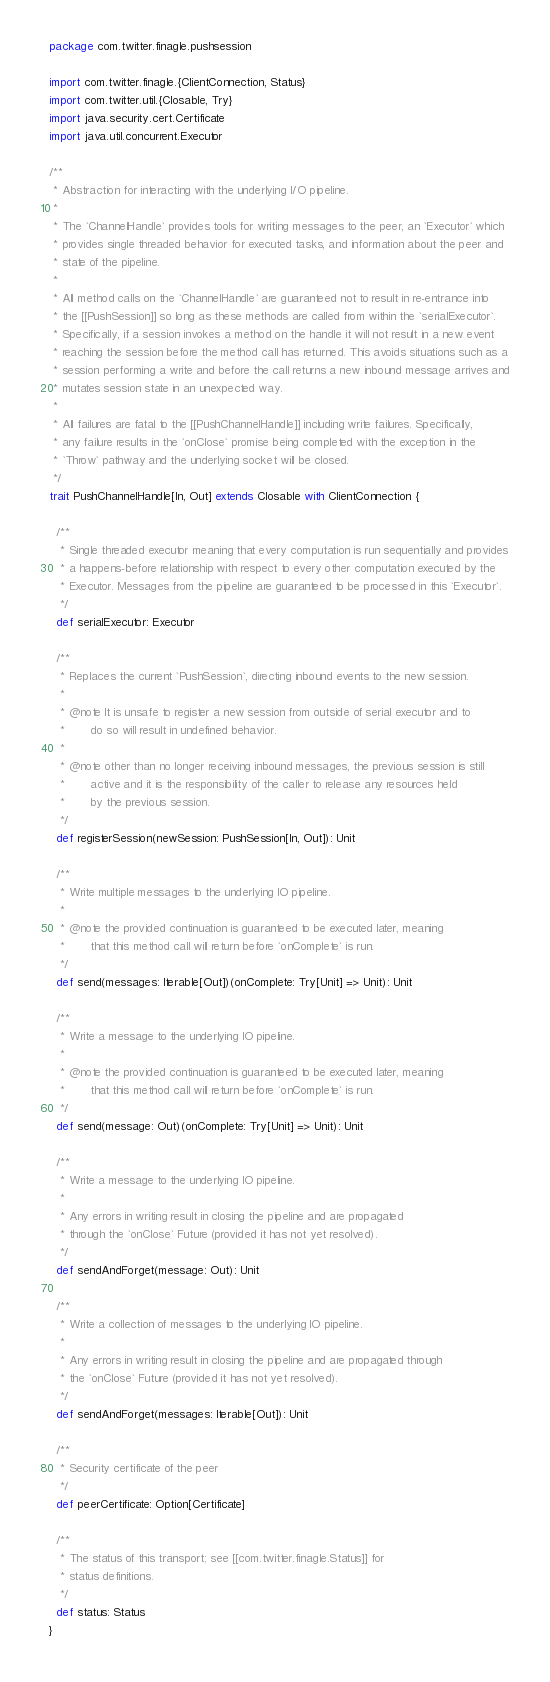<code> <loc_0><loc_0><loc_500><loc_500><_Scala_>package com.twitter.finagle.pushsession

import com.twitter.finagle.{ClientConnection, Status}
import com.twitter.util.{Closable, Try}
import java.security.cert.Certificate
import java.util.concurrent.Executor

/**
 * Abstraction for interacting with the underlying I/O pipeline.
 *
 * The `ChannelHandle` provides tools for writing messages to the peer, an `Executor` which
 * provides single threaded behavior for executed tasks, and information about the peer and
 * state of the pipeline.
 *
 * All method calls on the `ChannelHandle` are guaranteed not to result in re-entrance into
 * the [[PushSession]] so long as these methods are called from within the `serialExecutor`.
 * Specifically, if a session invokes a method on the handle it will not result in a new event
 * reaching the session before the method call has returned. This avoids situations such as a
 * session performing a write and before the call returns a new inbound message arrives and
 * mutates session state in an unexpected way.
 *
 * All failures are fatal to the [[PushChannelHandle]] including write failures. Specifically,
 * any failure results in the `onClose` promise being completed with the exception in the
 * `Throw` pathway and the underlying socket will be closed.
 */
trait PushChannelHandle[In, Out] extends Closable with ClientConnection {

  /**
   * Single threaded executor meaning that every computation is run sequentially and provides
   * a happens-before relationship with respect to every other computation executed by the
   * Executor. Messages from the pipeline are guaranteed to be processed in this `Executor`.
   */
  def serialExecutor: Executor

  /**
   * Replaces the current `PushSession`, directing inbound events to the new session.
   *
   * @note It is unsafe to register a new session from outside of serial executor and to
   *       do so will result in undefined behavior.
   *
   * @note other than no longer receiving inbound messages, the previous session is still
   *       active and it is the responsibility of the caller to release any resources held
   *       by the previous session.
   */
  def registerSession(newSession: PushSession[In, Out]): Unit

  /**
   * Write multiple messages to the underlying IO pipeline.
   *
   * @note the provided continuation is guaranteed to be executed later, meaning
   *       that this method call will return before `onComplete` is run.
   */
  def send(messages: Iterable[Out])(onComplete: Try[Unit] => Unit): Unit

  /**
   * Write a message to the underlying IO pipeline.
   *
   * @note the provided continuation is guaranteed to be executed later, meaning
   *       that this method call will return before `onComplete` is run.
   */
  def send(message: Out)(onComplete: Try[Unit] => Unit): Unit

  /**
   * Write a message to the underlying IO pipeline.
   *
   * Any errors in writing result in closing the pipeline and are propagated
   * through the `onClose` Future (provided it has not yet resolved).
   */
  def sendAndForget(message: Out): Unit

  /**
   * Write a collection of messages to the underlying IO pipeline.
   *
   * Any errors in writing result in closing the pipeline and are propagated through
   * the `onClose` Future (provided it has not yet resolved).
   */
  def sendAndForget(messages: Iterable[Out]): Unit

  /**
   * Security certificate of the peer
   */
  def peerCertificate: Option[Certificate]

  /**
   * The status of this transport; see [[com.twitter.finagle.Status]] for
   * status definitions.
   */
  def status: Status
}
</code> 